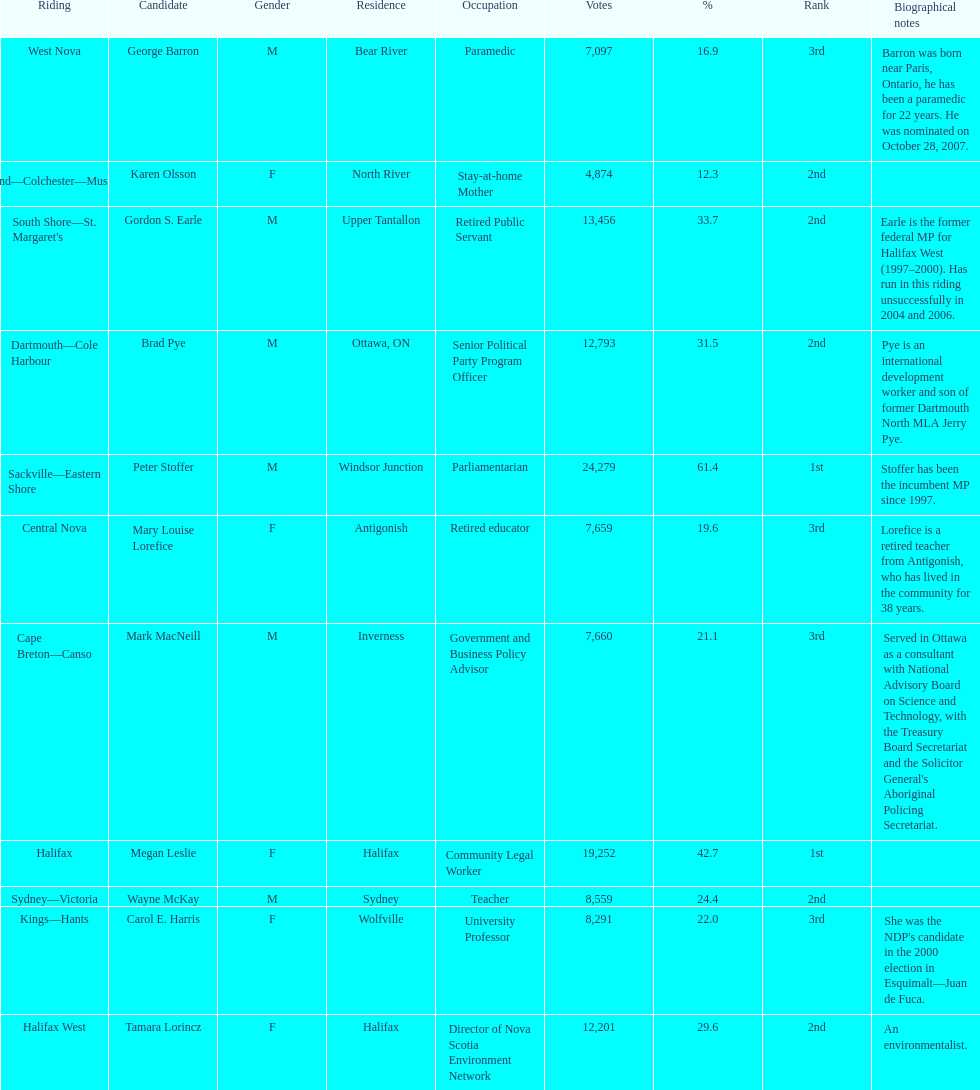I'm looking to parse the entire table for insights. Could you assist me with that? {'header': ['Riding', 'Candidate', 'Gender', 'Residence', 'Occupation', 'Votes', '%', 'Rank', 'Biographical notes'], 'rows': [['West Nova', 'George Barron', 'M', 'Bear River', 'Paramedic', '7,097', '16.9', '3rd', 'Barron was born near Paris, Ontario, he has been a paramedic for 22 years. He was nominated on October 28, 2007.'], ['Cumberland—Colchester—Musquodoboit Valley', 'Karen Olsson', 'F', 'North River', 'Stay-at-home Mother', '4,874', '12.3', '2nd', ''], ["South Shore—St. Margaret's", 'Gordon S. Earle', 'M', 'Upper Tantallon', 'Retired Public Servant', '13,456', '33.7', '2nd', 'Earle is the former federal MP for Halifax West (1997–2000). Has run in this riding unsuccessfully in 2004 and 2006.'], ['Dartmouth—Cole Harbour', 'Brad Pye', 'M', 'Ottawa, ON', 'Senior Political Party Program Officer', '12,793', '31.5', '2nd', 'Pye is an international development worker and son of former Dartmouth North MLA Jerry Pye.'], ['Sackville—Eastern Shore', 'Peter Stoffer', 'M', 'Windsor Junction', 'Parliamentarian', '24,279', '61.4', '1st', 'Stoffer has been the incumbent MP since 1997.'], ['Central Nova', 'Mary Louise Lorefice', 'F', 'Antigonish', 'Retired educator', '7,659', '19.6', '3rd', 'Lorefice is a retired teacher from Antigonish, who has lived in the community for 38 years.'], ['Cape Breton—Canso', 'Mark MacNeill', 'M', 'Inverness', 'Government and Business Policy Advisor', '7,660', '21.1', '3rd', "Served in Ottawa as a consultant with National Advisory Board on Science and Technology, with the Treasury Board Secretariat and the Solicitor General's Aboriginal Policing Secretariat."], ['Halifax', 'Megan Leslie', 'F', 'Halifax', 'Community Legal Worker', '19,252', '42.7', '1st', ''], ['Sydney—Victoria', 'Wayne McKay', 'M', 'Sydney', 'Teacher', '8,559', '24.4', '2nd', ''], ['Kings—Hants', 'Carol E. Harris', 'F', 'Wolfville', 'University Professor', '8,291', '22.0', '3rd', "She was the NDP's candidate in the 2000 election in Esquimalt—Juan de Fuca."], ['Halifax West', 'Tamara Lorincz', 'F', 'Halifax', 'Director of Nova Scotia Environment Network', '12,201', '29.6', '2nd', 'An environmentalist.']]} Who received the least amount of votes? Karen Olsson. 